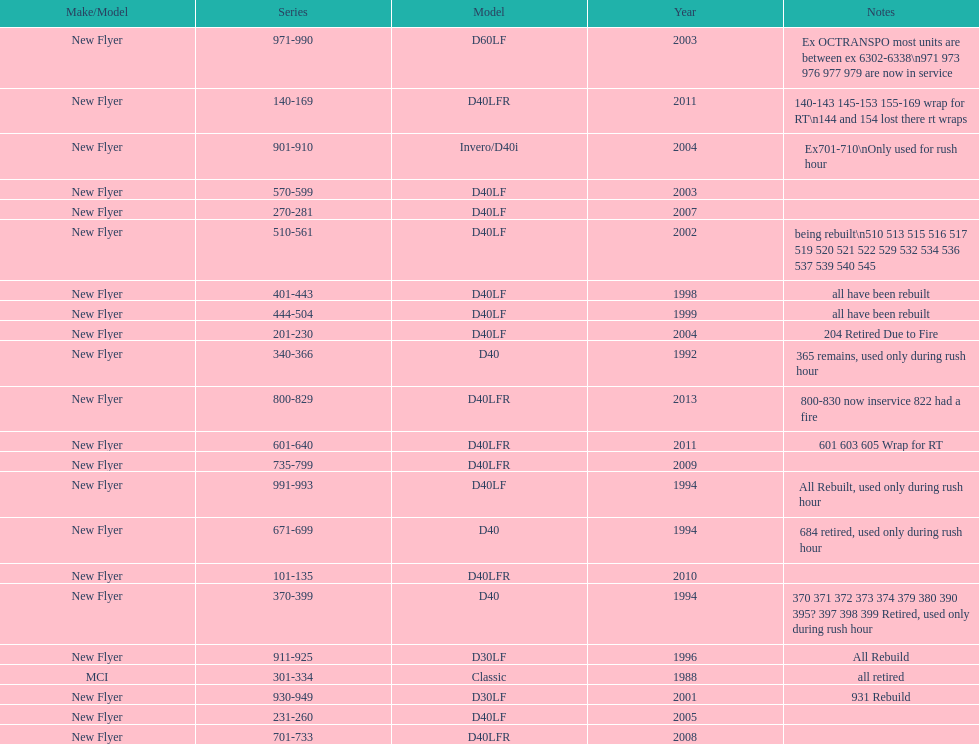Which buses are the newest in the current fleet? 800-829. 